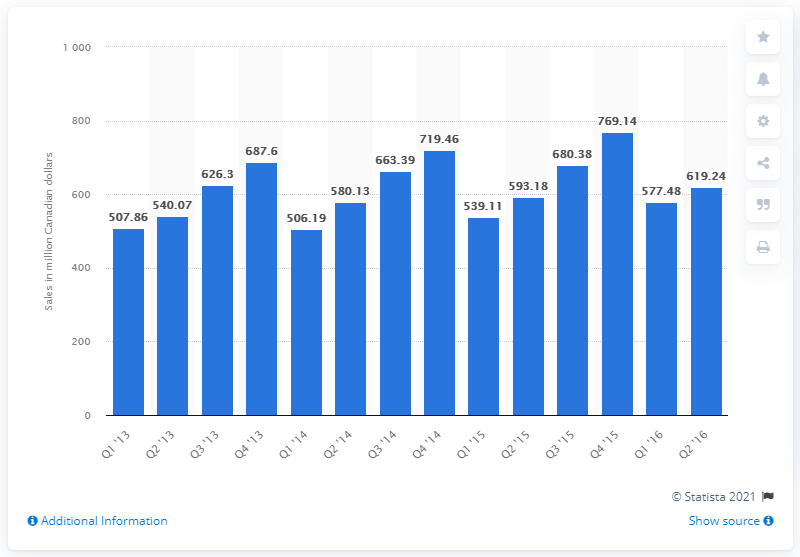Indicate a few pertinent items in this graphic. In the first quarter of 2013, the retail sales of bedding, linens, and bathroom accessories in Canada were 506.19 million units. 